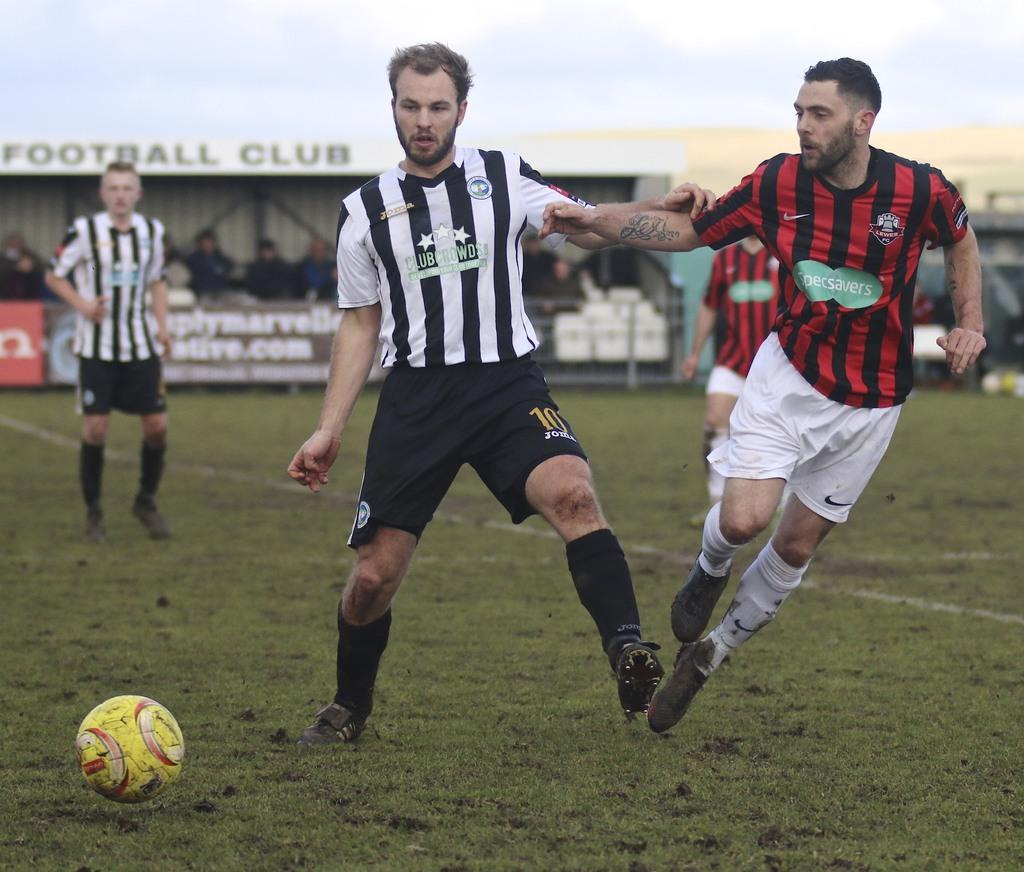<image>
Describe the image concisely. A soccer player from Club Crown pushes off a Specsavers player 